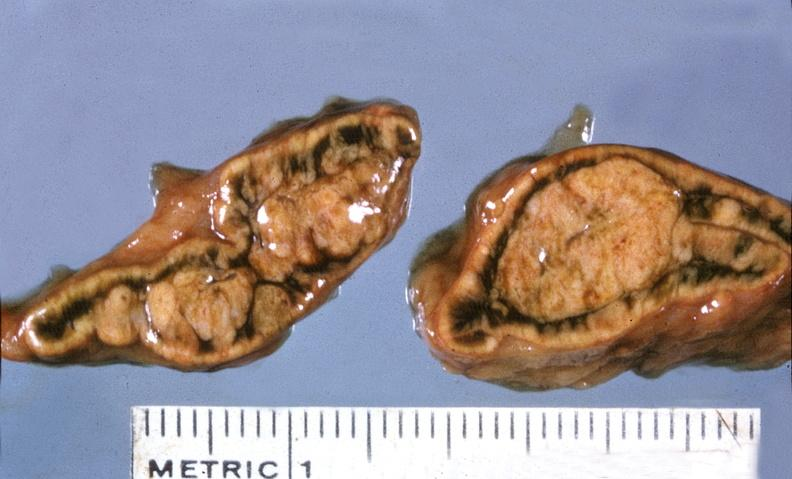does lymphangiomatosis show adrenal, cortical adenoma?
Answer the question using a single word or phrase. No 